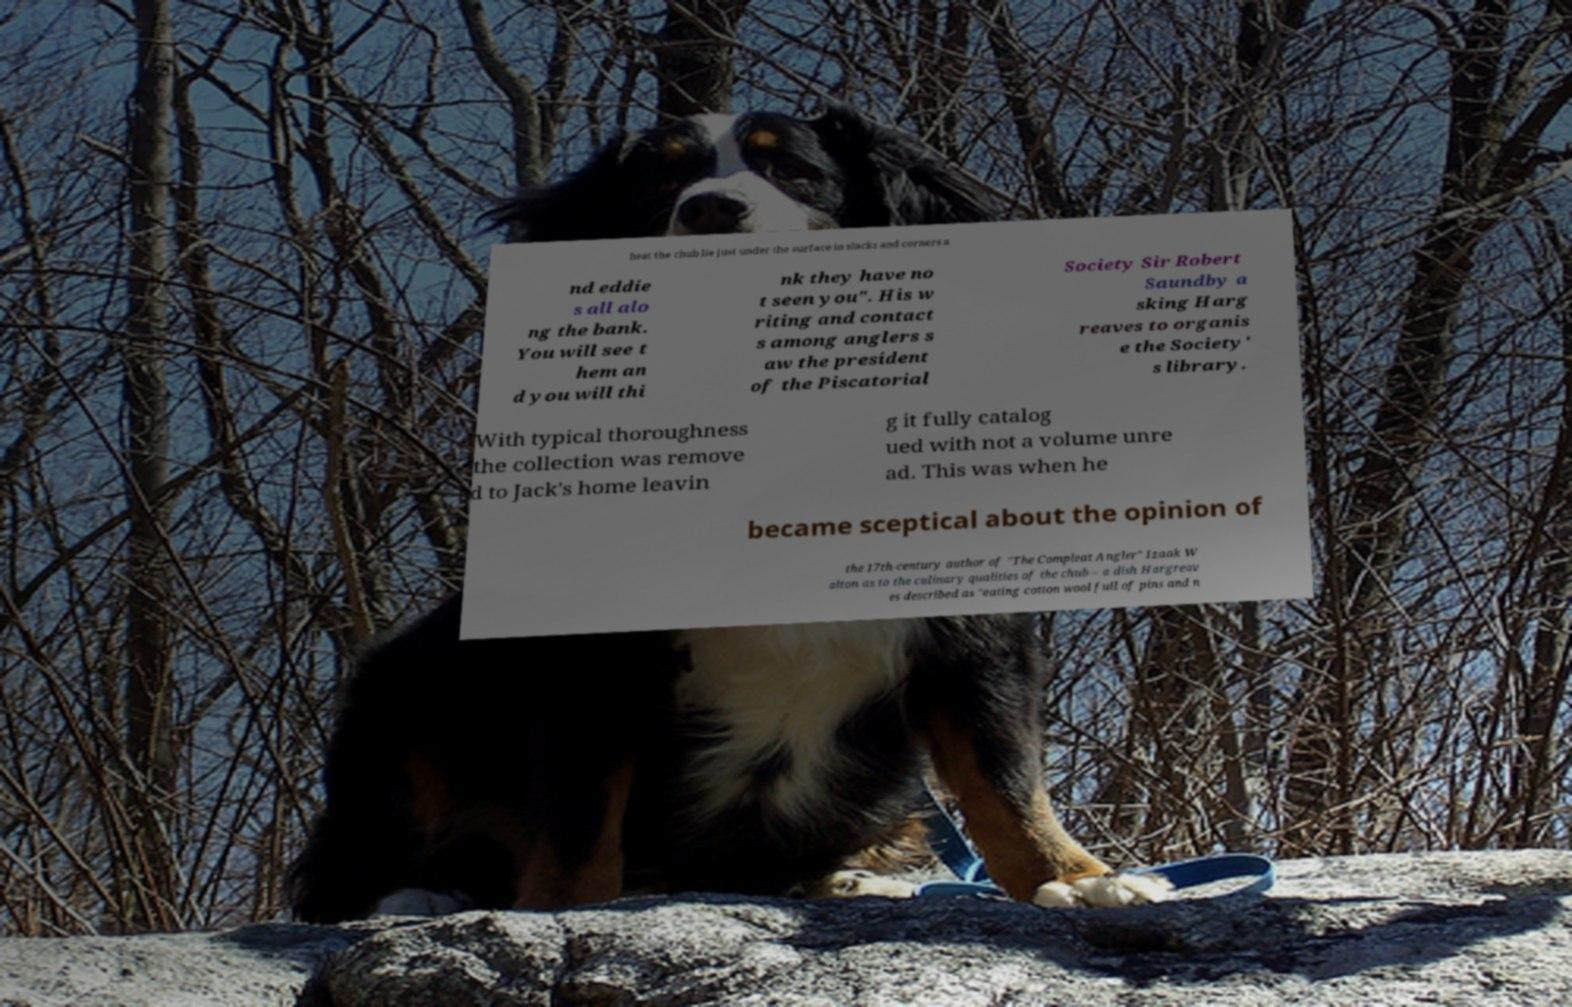What messages or text are displayed in this image? I need them in a readable, typed format. heat the chub lie just under the surface in slacks and corners a nd eddie s all alo ng the bank. You will see t hem an d you will thi nk they have no t seen you". His w riting and contact s among anglers s aw the president of the Piscatorial Society Sir Robert Saundby a sking Harg reaves to organis e the Society' s library. With typical thoroughness the collection was remove d to Jack's home leavin g it fully catalog ued with not a volume unre ad. This was when he became sceptical about the opinion of the 17th-century author of "The Compleat Angler" Izaak W alton as to the culinary qualities of the chub – a dish Hargreav es described as "eating cotton wool full of pins and n 